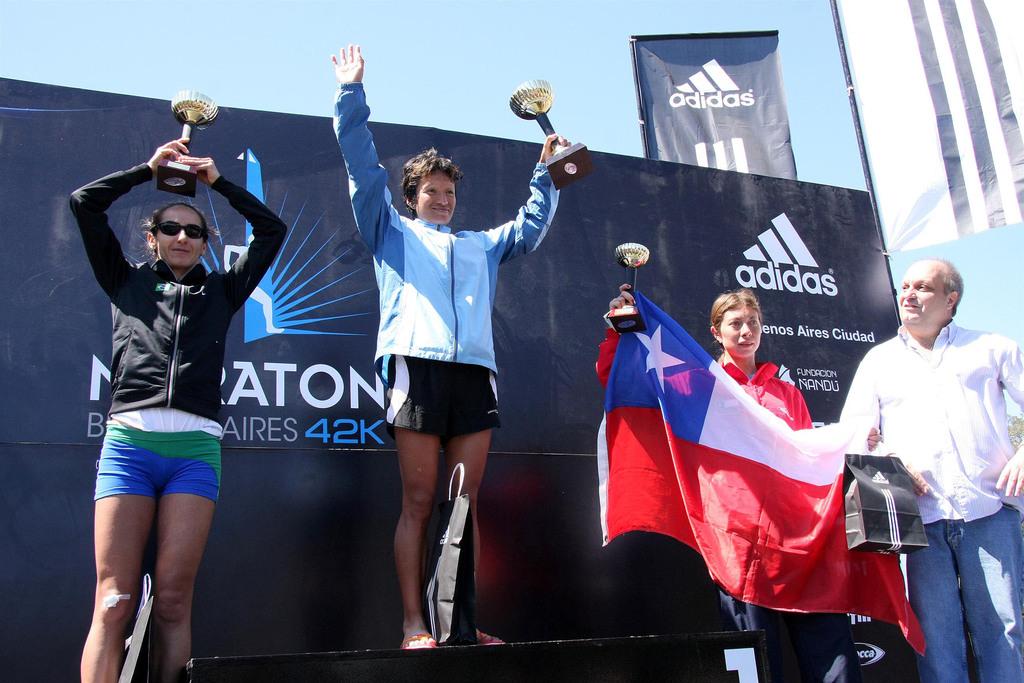What brand name is displayed in the back ?
Offer a very short reply. Adidas. 